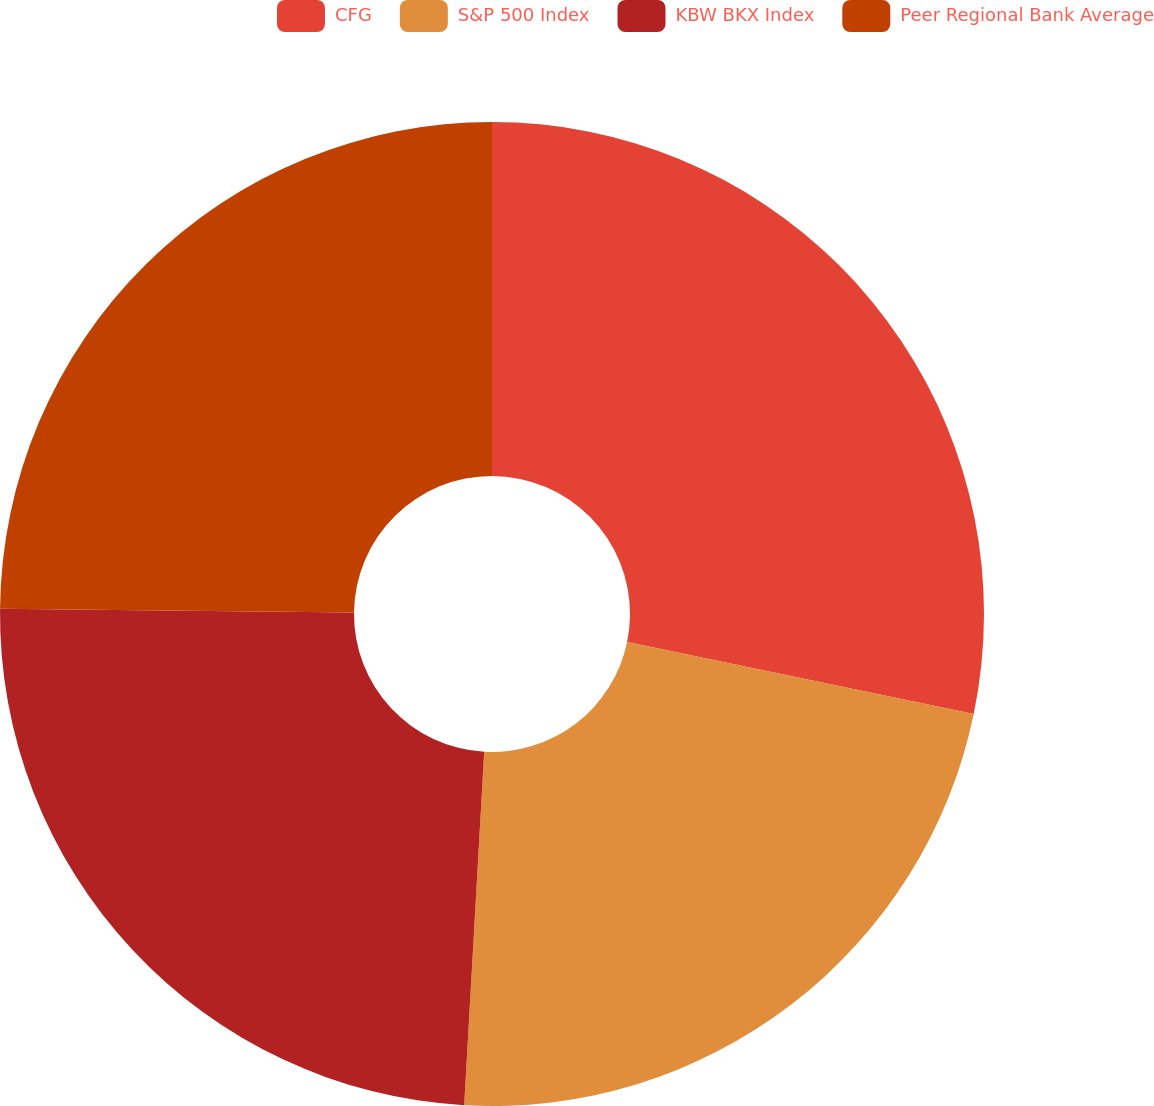<chart> <loc_0><loc_0><loc_500><loc_500><pie_chart><fcel>CFG<fcel>S&P 500 Index<fcel>KBW BKX Index<fcel>Peer Regional Bank Average<nl><fcel>28.26%<fcel>22.64%<fcel>24.27%<fcel>24.83%<nl></chart> 